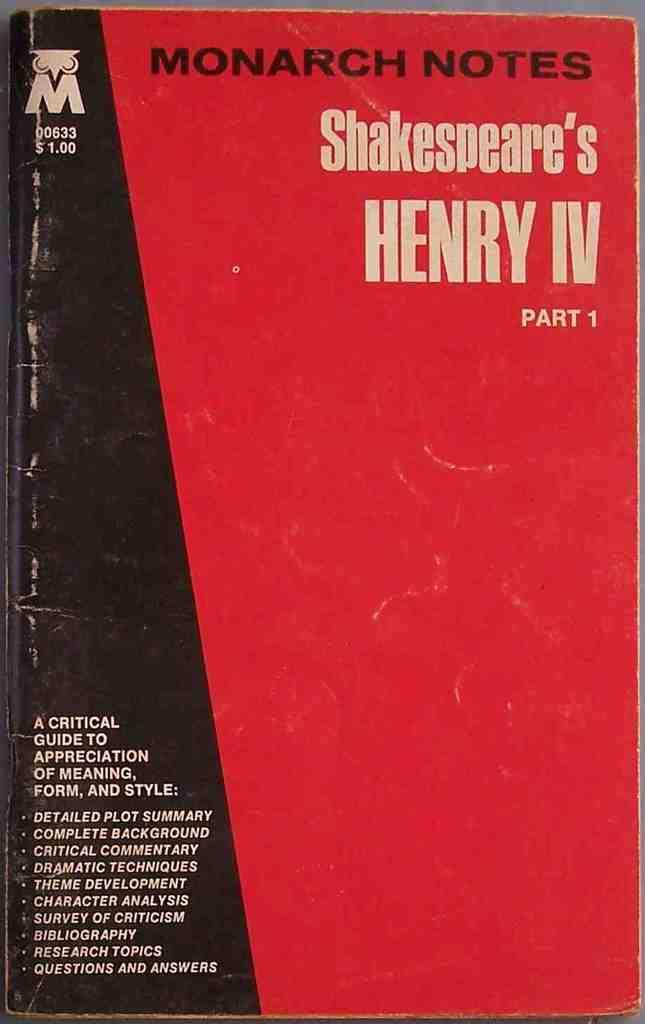What is the title of the book?
Offer a very short reply. Henry iv. How much did this book cost?
Your answer should be very brief. $1.00. 